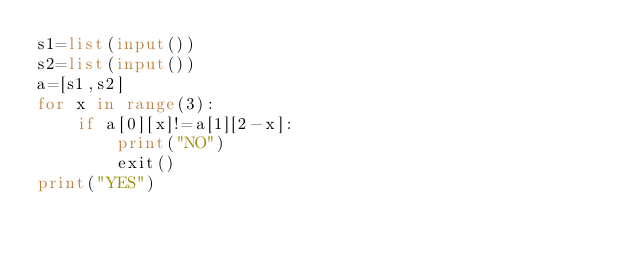Convert code to text. <code><loc_0><loc_0><loc_500><loc_500><_Python_>s1=list(input())
s2=list(input())
a=[s1,s2]
for x in range(3):
    if a[0][x]!=a[1][2-x]:
        print("NO")
        exit()
print("YES")
</code> 